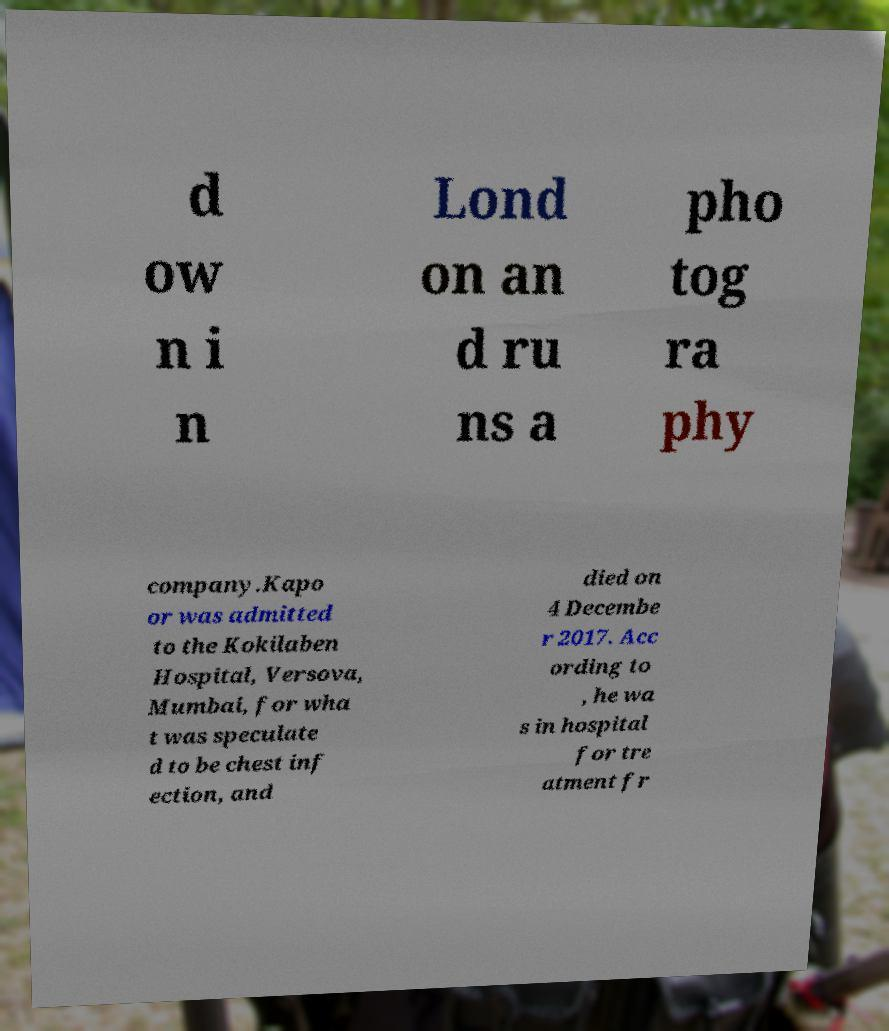Please identify and transcribe the text found in this image. d ow n i n Lond on an d ru ns a pho tog ra phy company.Kapo or was admitted to the Kokilaben Hospital, Versova, Mumbai, for wha t was speculate d to be chest inf ection, and died on 4 Decembe r 2017. Acc ording to , he wa s in hospital for tre atment fr 